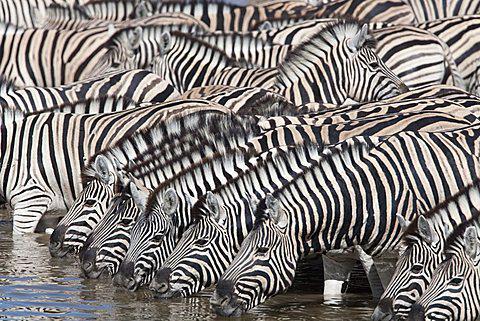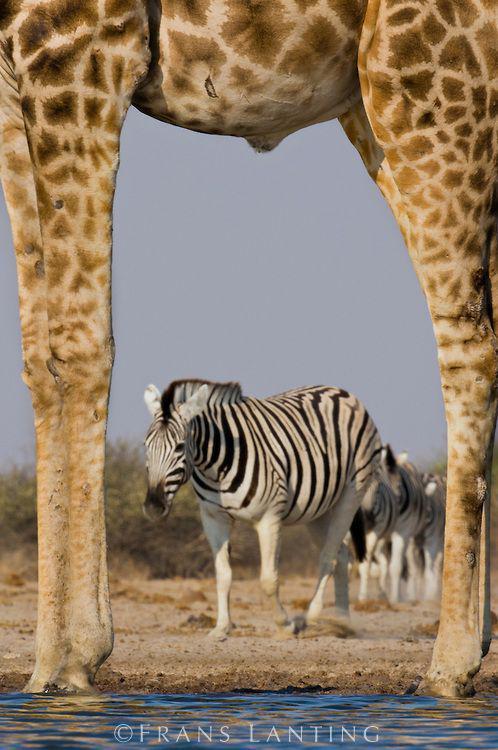The first image is the image on the left, the second image is the image on the right. Analyze the images presented: Is the assertion "The left image contains no more than three zebras." valid? Answer yes or no. No. The first image is the image on the left, the second image is the image on the right. Analyze the images presented: Is the assertion "One image shows at least 8 zebras lined up close together to drink, and the other image shows a zebra and a different type of animal near a pool of water." valid? Answer yes or no. Yes. 